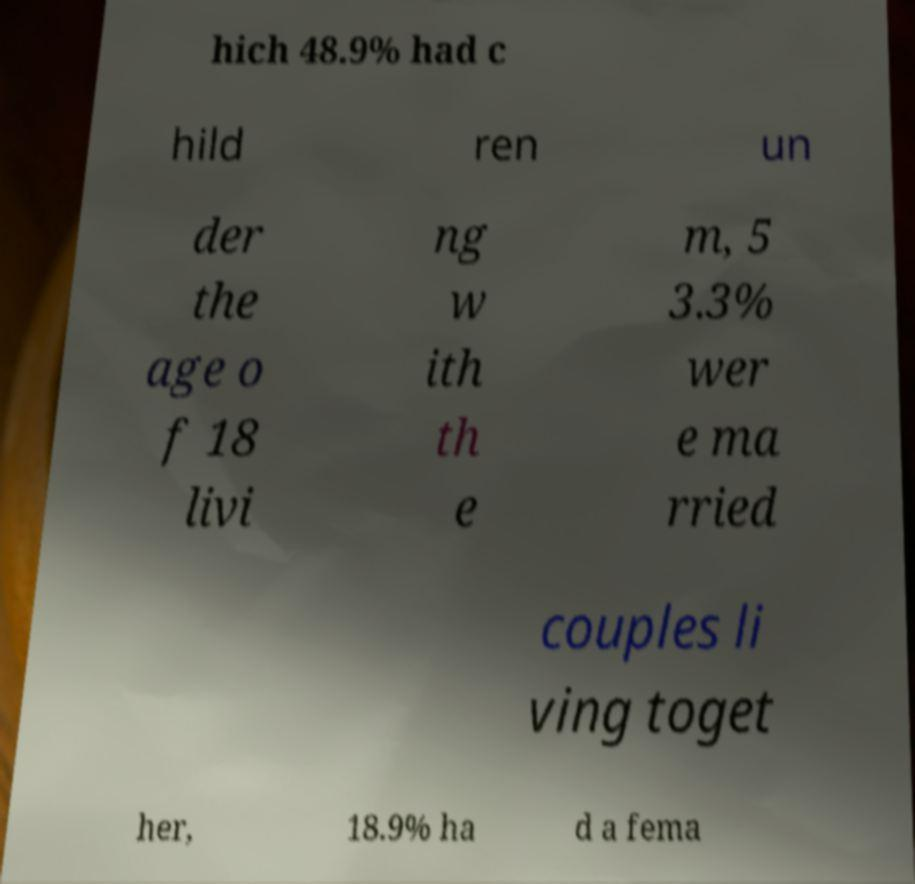Can you accurately transcribe the text from the provided image for me? hich 48.9% had c hild ren un der the age o f 18 livi ng w ith th e m, 5 3.3% wer e ma rried couples li ving toget her, 18.9% ha d a fema 